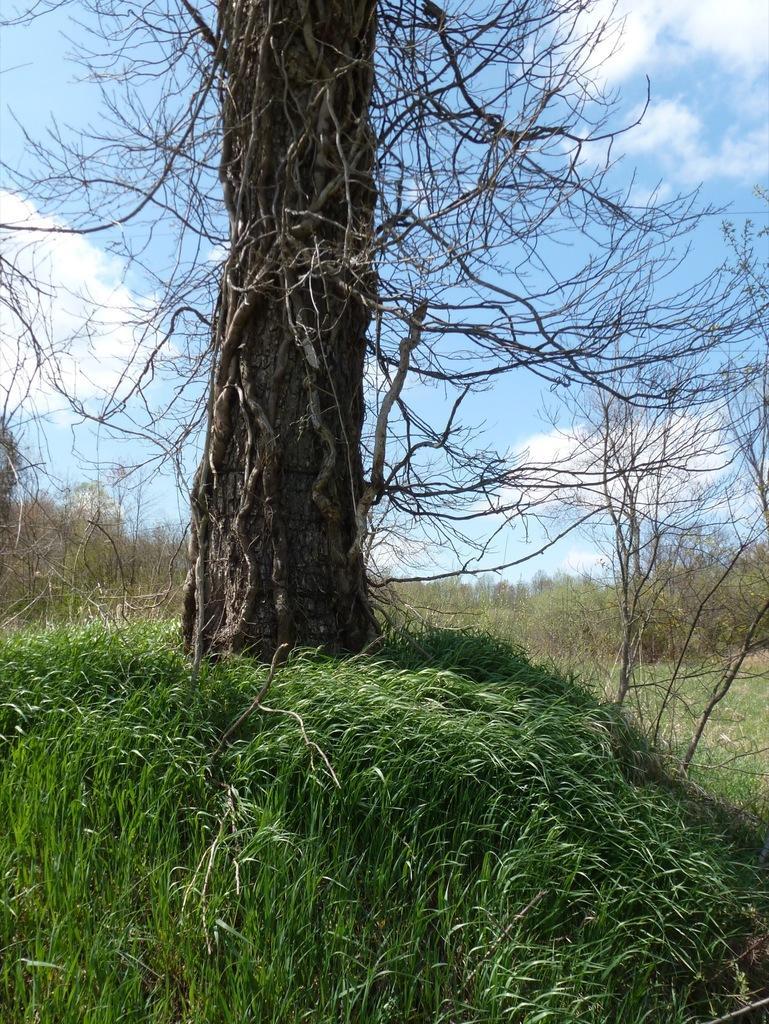How would you summarize this image in a sentence or two? In this image there is grass and trees, at the top of the image there are clouds in the sky. 